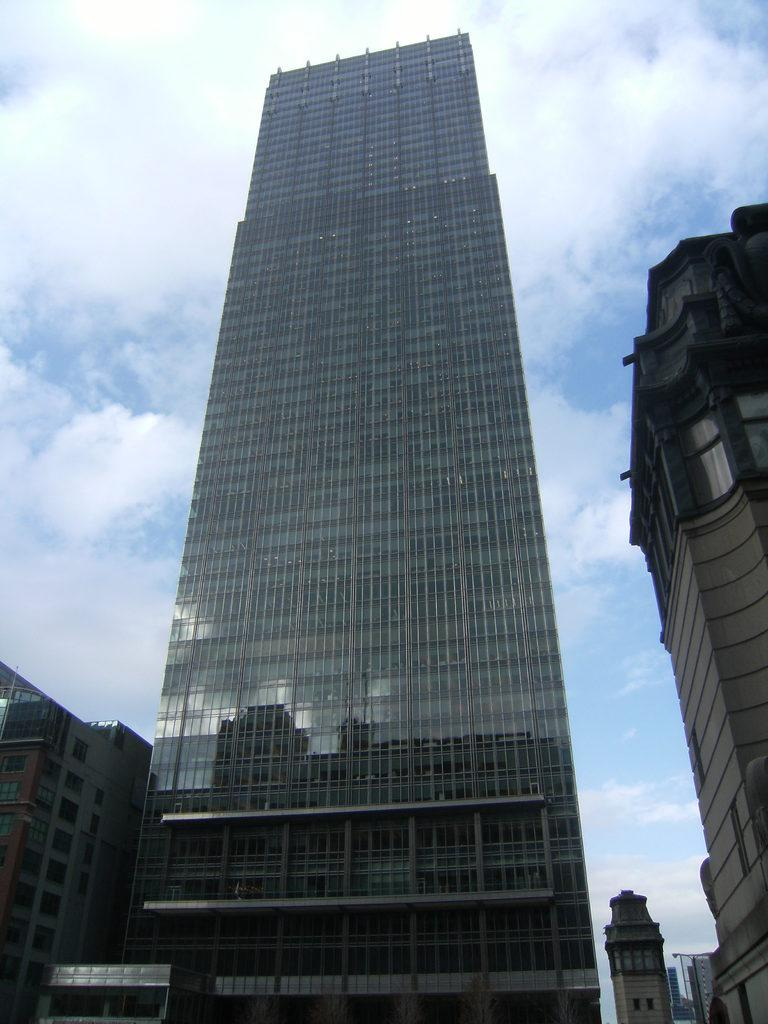What structures are located at the bottom of the image? There are buildings at the bottom of the image. What can be seen in the background of the image? The sky is visible in the background of the image. How would you describe the sky in the image? The sky appears to be cloudy. What type of sweater is being worn by the cloud in the image? There are no clouds or sweaters present in the image. How many stamps are visible on the quilt in the image? There are no quilts or stamps present in the image. 